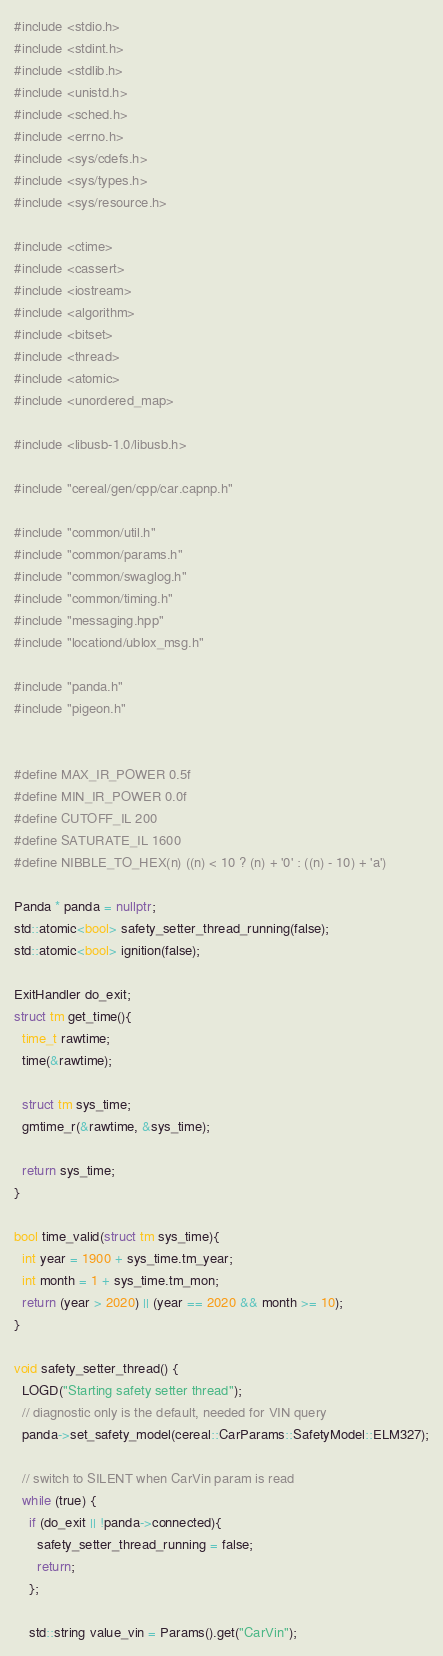Convert code to text. <code><loc_0><loc_0><loc_500><loc_500><_C++_>#include <stdio.h>
#include <stdint.h>
#include <stdlib.h>
#include <unistd.h>
#include <sched.h>
#include <errno.h>
#include <sys/cdefs.h>
#include <sys/types.h>
#include <sys/resource.h>

#include <ctime>
#include <cassert>
#include <iostream>
#include <algorithm>
#include <bitset>
#include <thread>
#include <atomic>
#include <unordered_map>

#include <libusb-1.0/libusb.h>

#include "cereal/gen/cpp/car.capnp.h"

#include "common/util.h"
#include "common/params.h"
#include "common/swaglog.h"
#include "common/timing.h"
#include "messaging.hpp"
#include "locationd/ublox_msg.h"

#include "panda.h"
#include "pigeon.h"


#define MAX_IR_POWER 0.5f
#define MIN_IR_POWER 0.0f
#define CUTOFF_IL 200
#define SATURATE_IL 1600
#define NIBBLE_TO_HEX(n) ((n) < 10 ? (n) + '0' : ((n) - 10) + 'a')

Panda * panda = nullptr;
std::atomic<bool> safety_setter_thread_running(false);
std::atomic<bool> ignition(false);

ExitHandler do_exit;
struct tm get_time(){
  time_t rawtime;
  time(&rawtime);

  struct tm sys_time;
  gmtime_r(&rawtime, &sys_time);

  return sys_time;
}

bool time_valid(struct tm sys_time){
  int year = 1900 + sys_time.tm_year;
  int month = 1 + sys_time.tm_mon;
  return (year > 2020) || (year == 2020 && month >= 10);
}

void safety_setter_thread() {
  LOGD("Starting safety setter thread");
  // diagnostic only is the default, needed for VIN query
  panda->set_safety_model(cereal::CarParams::SafetyModel::ELM327);

  // switch to SILENT when CarVin param is read
  while (true) {
    if (do_exit || !panda->connected){
      safety_setter_thread_running = false;
      return;
    };

    std::string value_vin = Params().get("CarVin");</code> 